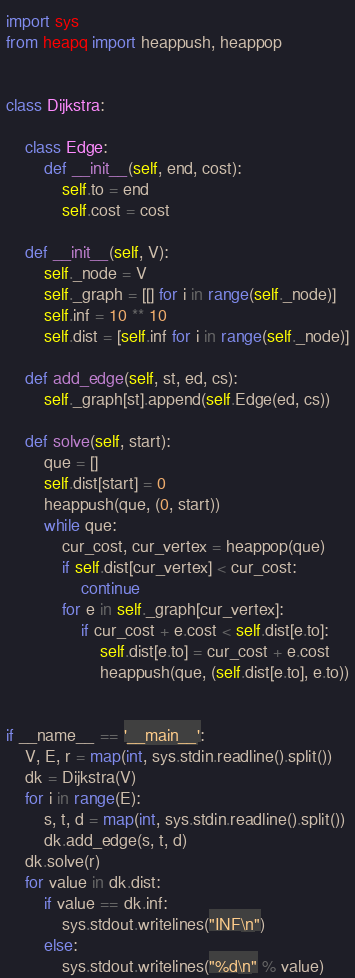Convert code to text. <code><loc_0><loc_0><loc_500><loc_500><_Python_>import sys
from heapq import heappush, heappop


class Dijkstra:

    class Edge:
        def __init__(self, end, cost):
            self.to = end
            self.cost = cost

    def __init__(self, V):
        self._node = V
        self._graph = [[] for i in range(self._node)]
        self.inf = 10 ** 10
        self.dist = [self.inf for i in range(self._node)]

    def add_edge(self, st, ed, cs):
        self._graph[st].append(self.Edge(ed, cs))

    def solve(self, start):
        que = []
        self.dist[start] = 0
        heappush(que, (0, start))
        while que:
            cur_cost, cur_vertex = heappop(que)
            if self.dist[cur_vertex] < cur_cost:
                continue
            for e in self._graph[cur_vertex]:
                if cur_cost + e.cost < self.dist[e.to]:
                    self.dist[e.to] = cur_cost + e.cost
                    heappush(que, (self.dist[e.to], e.to))


if __name__ == '__main__':
    V, E, r = map(int, sys.stdin.readline().split())
    dk = Dijkstra(V)
    for i in range(E):
        s, t, d = map(int, sys.stdin.readline().split())
        dk.add_edge(s, t, d)
    dk.solve(r)
    for value in dk.dist:
        if value == dk.inf:
            sys.stdout.writelines("INF\n")
        else:
            sys.stdout.writelines("%d\n" % value)

</code> 